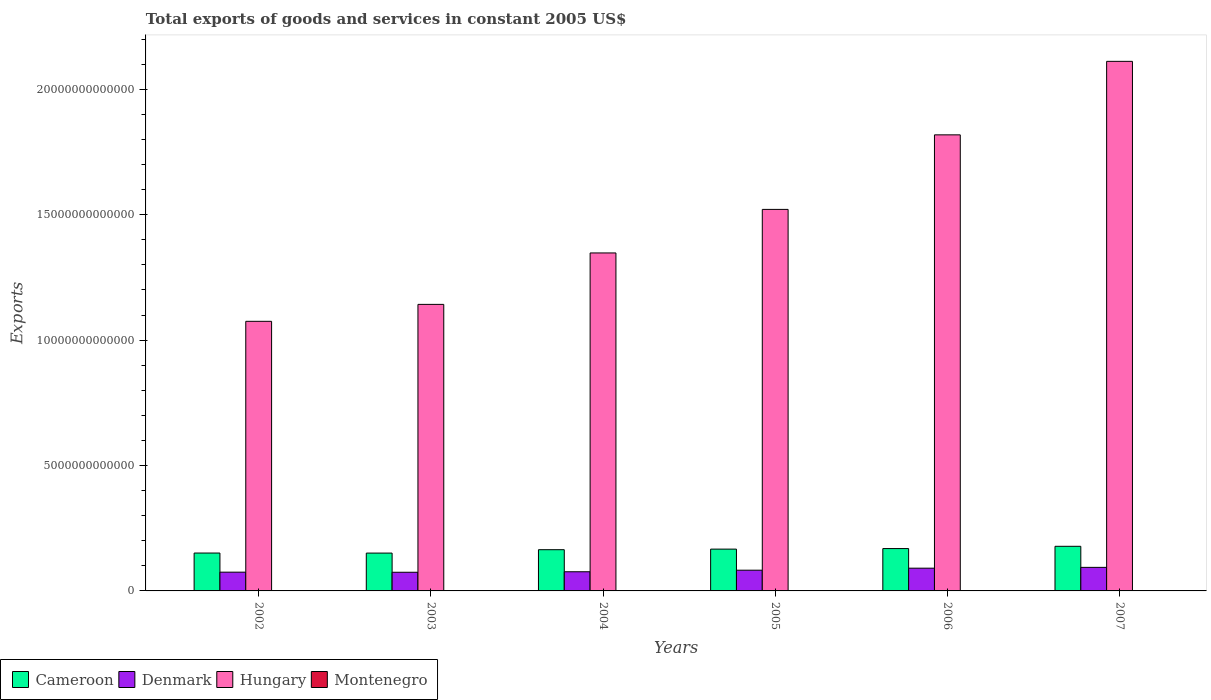How many groups of bars are there?
Your answer should be very brief. 6. Are the number of bars per tick equal to the number of legend labels?
Provide a succinct answer. Yes. How many bars are there on the 4th tick from the left?
Provide a short and direct response. 4. How many bars are there on the 6th tick from the right?
Your answer should be very brief. 4. What is the label of the 6th group of bars from the left?
Provide a succinct answer. 2007. What is the total exports of goods and services in Cameroon in 2005?
Ensure brevity in your answer.  1.67e+12. Across all years, what is the maximum total exports of goods and services in Cameroon?
Provide a succinct answer. 1.78e+12. Across all years, what is the minimum total exports of goods and services in Denmark?
Provide a short and direct response. 7.44e+11. In which year was the total exports of goods and services in Cameroon minimum?
Provide a short and direct response. 2003. What is the total total exports of goods and services in Hungary in the graph?
Your answer should be compact. 9.02e+13. What is the difference between the total exports of goods and services in Hungary in 2002 and that in 2003?
Keep it short and to the point. -6.75e+11. What is the difference between the total exports of goods and services in Cameroon in 2007 and the total exports of goods and services in Hungary in 2004?
Provide a succinct answer. -1.17e+13. What is the average total exports of goods and services in Montenegro per year?
Ensure brevity in your answer.  7.18e+08. In the year 2004, what is the difference between the total exports of goods and services in Hungary and total exports of goods and services in Denmark?
Offer a very short reply. 1.27e+13. What is the ratio of the total exports of goods and services in Hungary in 2002 to that in 2005?
Give a very brief answer. 0.71. Is the total exports of goods and services in Montenegro in 2002 less than that in 2005?
Your answer should be very brief. Yes. Is the difference between the total exports of goods and services in Hungary in 2003 and 2005 greater than the difference between the total exports of goods and services in Denmark in 2003 and 2005?
Ensure brevity in your answer.  No. What is the difference between the highest and the second highest total exports of goods and services in Denmark?
Your answer should be very brief. 3.24e+1. What is the difference between the highest and the lowest total exports of goods and services in Montenegro?
Ensure brevity in your answer.  5.13e+08. Is the sum of the total exports of goods and services in Montenegro in 2006 and 2007 greater than the maximum total exports of goods and services in Hungary across all years?
Your answer should be compact. No. What does the 2nd bar from the left in 2007 represents?
Provide a succinct answer. Denmark. What does the 2nd bar from the right in 2007 represents?
Keep it short and to the point. Hungary. Is it the case that in every year, the sum of the total exports of goods and services in Cameroon and total exports of goods and services in Denmark is greater than the total exports of goods and services in Hungary?
Your answer should be very brief. No. What is the difference between two consecutive major ticks on the Y-axis?
Make the answer very short. 5.00e+12. Are the values on the major ticks of Y-axis written in scientific E-notation?
Your response must be concise. No. Does the graph contain any zero values?
Ensure brevity in your answer.  No. Does the graph contain grids?
Your response must be concise. No. How many legend labels are there?
Your answer should be very brief. 4. What is the title of the graph?
Keep it short and to the point. Total exports of goods and services in constant 2005 US$. Does "Argentina" appear as one of the legend labels in the graph?
Provide a succinct answer. No. What is the label or title of the Y-axis?
Provide a short and direct response. Exports. What is the Exports of Cameroon in 2002?
Make the answer very short. 1.51e+12. What is the Exports of Denmark in 2002?
Offer a terse response. 7.48e+11. What is the Exports in Hungary in 2002?
Provide a short and direct response. 1.08e+13. What is the Exports in Montenegro in 2002?
Your answer should be very brief. 5.32e+08. What is the Exports in Cameroon in 2003?
Give a very brief answer. 1.51e+12. What is the Exports of Denmark in 2003?
Give a very brief answer. 7.44e+11. What is the Exports of Hungary in 2003?
Your answer should be compact. 1.14e+13. What is the Exports of Montenegro in 2003?
Make the answer very short. 4.53e+08. What is the Exports in Cameroon in 2004?
Keep it short and to the point. 1.64e+12. What is the Exports of Denmark in 2004?
Give a very brief answer. 7.64e+11. What is the Exports in Hungary in 2004?
Provide a short and direct response. 1.35e+13. What is the Exports in Montenegro in 2004?
Offer a terse response. 6.65e+08. What is the Exports of Cameroon in 2005?
Your answer should be compact. 1.67e+12. What is the Exports of Denmark in 2005?
Give a very brief answer. 8.26e+11. What is the Exports of Hungary in 2005?
Offer a very short reply. 1.52e+13. What is the Exports of Montenegro in 2005?
Provide a succinct answer. 7.45e+08. What is the Exports of Cameroon in 2006?
Offer a terse response. 1.69e+12. What is the Exports of Denmark in 2006?
Offer a very short reply. 9.07e+11. What is the Exports of Hungary in 2006?
Your answer should be very brief. 1.82e+13. What is the Exports in Montenegro in 2006?
Offer a terse response. 9.46e+08. What is the Exports in Cameroon in 2007?
Ensure brevity in your answer.  1.78e+12. What is the Exports in Denmark in 2007?
Your response must be concise. 9.39e+11. What is the Exports of Hungary in 2007?
Offer a terse response. 2.11e+13. What is the Exports of Montenegro in 2007?
Offer a terse response. 9.66e+08. Across all years, what is the maximum Exports of Cameroon?
Your answer should be very brief. 1.78e+12. Across all years, what is the maximum Exports in Denmark?
Give a very brief answer. 9.39e+11. Across all years, what is the maximum Exports in Hungary?
Provide a short and direct response. 2.11e+13. Across all years, what is the maximum Exports of Montenegro?
Offer a very short reply. 9.66e+08. Across all years, what is the minimum Exports in Cameroon?
Keep it short and to the point. 1.51e+12. Across all years, what is the minimum Exports of Denmark?
Keep it short and to the point. 7.44e+11. Across all years, what is the minimum Exports in Hungary?
Ensure brevity in your answer.  1.08e+13. Across all years, what is the minimum Exports in Montenegro?
Your answer should be compact. 4.53e+08. What is the total Exports in Cameroon in the graph?
Provide a succinct answer. 9.80e+12. What is the total Exports of Denmark in the graph?
Offer a very short reply. 4.93e+12. What is the total Exports of Hungary in the graph?
Your response must be concise. 9.02e+13. What is the total Exports of Montenegro in the graph?
Your response must be concise. 4.31e+09. What is the difference between the Exports in Cameroon in 2002 and that in 2003?
Your response must be concise. 1.63e+09. What is the difference between the Exports of Denmark in 2002 and that in 2003?
Ensure brevity in your answer.  3.36e+09. What is the difference between the Exports of Hungary in 2002 and that in 2003?
Your answer should be very brief. -6.75e+11. What is the difference between the Exports of Montenegro in 2002 and that in 2003?
Your answer should be compact. 7.89e+07. What is the difference between the Exports of Cameroon in 2002 and that in 2004?
Give a very brief answer. -1.34e+11. What is the difference between the Exports in Denmark in 2002 and that in 2004?
Ensure brevity in your answer.  -1.63e+1. What is the difference between the Exports in Hungary in 2002 and that in 2004?
Make the answer very short. -2.73e+12. What is the difference between the Exports of Montenegro in 2002 and that in 2004?
Your response must be concise. -1.33e+08. What is the difference between the Exports of Cameroon in 2002 and that in 2005?
Make the answer very short. -1.57e+11. What is the difference between the Exports in Denmark in 2002 and that in 2005?
Give a very brief answer. -7.84e+1. What is the difference between the Exports of Hungary in 2002 and that in 2005?
Your response must be concise. -4.46e+12. What is the difference between the Exports in Montenegro in 2002 and that in 2005?
Offer a terse response. -2.13e+08. What is the difference between the Exports of Cameroon in 2002 and that in 2006?
Provide a short and direct response. -1.79e+11. What is the difference between the Exports of Denmark in 2002 and that in 2006?
Keep it short and to the point. -1.59e+11. What is the difference between the Exports of Hungary in 2002 and that in 2006?
Give a very brief answer. -7.44e+12. What is the difference between the Exports of Montenegro in 2002 and that in 2006?
Give a very brief answer. -4.14e+08. What is the difference between the Exports in Cameroon in 2002 and that in 2007?
Offer a very short reply. -2.69e+11. What is the difference between the Exports of Denmark in 2002 and that in 2007?
Provide a short and direct response. -1.92e+11. What is the difference between the Exports in Hungary in 2002 and that in 2007?
Give a very brief answer. -1.04e+13. What is the difference between the Exports of Montenegro in 2002 and that in 2007?
Make the answer very short. -4.34e+08. What is the difference between the Exports in Cameroon in 2003 and that in 2004?
Your answer should be very brief. -1.35e+11. What is the difference between the Exports in Denmark in 2003 and that in 2004?
Your response must be concise. -1.96e+1. What is the difference between the Exports of Hungary in 2003 and that in 2004?
Your answer should be compact. -2.05e+12. What is the difference between the Exports of Montenegro in 2003 and that in 2004?
Your answer should be compact. -2.12e+08. What is the difference between the Exports of Cameroon in 2003 and that in 2005?
Offer a very short reply. -1.58e+11. What is the difference between the Exports of Denmark in 2003 and that in 2005?
Your answer should be very brief. -8.18e+1. What is the difference between the Exports in Hungary in 2003 and that in 2005?
Your answer should be very brief. -3.79e+12. What is the difference between the Exports of Montenegro in 2003 and that in 2005?
Keep it short and to the point. -2.92e+08. What is the difference between the Exports in Cameroon in 2003 and that in 2006?
Your answer should be compact. -1.80e+11. What is the difference between the Exports of Denmark in 2003 and that in 2006?
Your answer should be compact. -1.63e+11. What is the difference between the Exports in Hungary in 2003 and that in 2006?
Give a very brief answer. -6.76e+12. What is the difference between the Exports of Montenegro in 2003 and that in 2006?
Your answer should be very brief. -4.93e+08. What is the difference between the Exports of Cameroon in 2003 and that in 2007?
Provide a succinct answer. -2.70e+11. What is the difference between the Exports of Denmark in 2003 and that in 2007?
Ensure brevity in your answer.  -1.95e+11. What is the difference between the Exports in Hungary in 2003 and that in 2007?
Provide a succinct answer. -9.69e+12. What is the difference between the Exports in Montenegro in 2003 and that in 2007?
Your answer should be very brief. -5.13e+08. What is the difference between the Exports of Cameroon in 2004 and that in 2005?
Provide a succinct answer. -2.32e+1. What is the difference between the Exports of Denmark in 2004 and that in 2005?
Give a very brief answer. -6.22e+1. What is the difference between the Exports in Hungary in 2004 and that in 2005?
Your answer should be compact. -1.74e+12. What is the difference between the Exports in Montenegro in 2004 and that in 2005?
Your answer should be compact. -8.00e+07. What is the difference between the Exports in Cameroon in 2004 and that in 2006?
Your response must be concise. -4.51e+1. What is the difference between the Exports of Denmark in 2004 and that in 2006?
Ensure brevity in your answer.  -1.43e+11. What is the difference between the Exports in Hungary in 2004 and that in 2006?
Give a very brief answer. -4.71e+12. What is the difference between the Exports in Montenegro in 2004 and that in 2006?
Your answer should be very brief. -2.81e+08. What is the difference between the Exports of Cameroon in 2004 and that in 2007?
Make the answer very short. -1.35e+11. What is the difference between the Exports in Denmark in 2004 and that in 2007?
Provide a succinct answer. -1.75e+11. What is the difference between the Exports of Hungary in 2004 and that in 2007?
Your answer should be compact. -7.64e+12. What is the difference between the Exports of Montenegro in 2004 and that in 2007?
Ensure brevity in your answer.  -3.01e+08. What is the difference between the Exports of Cameroon in 2005 and that in 2006?
Provide a short and direct response. -2.19e+1. What is the difference between the Exports in Denmark in 2005 and that in 2006?
Your answer should be compact. -8.09e+1. What is the difference between the Exports in Hungary in 2005 and that in 2006?
Your answer should be very brief. -2.97e+12. What is the difference between the Exports in Montenegro in 2005 and that in 2006?
Offer a very short reply. -2.01e+08. What is the difference between the Exports of Cameroon in 2005 and that in 2007?
Offer a terse response. -1.12e+11. What is the difference between the Exports of Denmark in 2005 and that in 2007?
Your answer should be compact. -1.13e+11. What is the difference between the Exports in Hungary in 2005 and that in 2007?
Offer a very short reply. -5.90e+12. What is the difference between the Exports in Montenegro in 2005 and that in 2007?
Your answer should be very brief. -2.21e+08. What is the difference between the Exports in Cameroon in 2006 and that in 2007?
Give a very brief answer. -9.02e+1. What is the difference between the Exports of Denmark in 2006 and that in 2007?
Ensure brevity in your answer.  -3.24e+1. What is the difference between the Exports of Hungary in 2006 and that in 2007?
Your response must be concise. -2.93e+12. What is the difference between the Exports of Montenegro in 2006 and that in 2007?
Provide a succinct answer. -2.01e+07. What is the difference between the Exports in Cameroon in 2002 and the Exports in Denmark in 2003?
Make the answer very short. 7.66e+11. What is the difference between the Exports of Cameroon in 2002 and the Exports of Hungary in 2003?
Keep it short and to the point. -9.92e+12. What is the difference between the Exports in Cameroon in 2002 and the Exports in Montenegro in 2003?
Provide a short and direct response. 1.51e+12. What is the difference between the Exports in Denmark in 2002 and the Exports in Hungary in 2003?
Provide a short and direct response. -1.07e+13. What is the difference between the Exports of Denmark in 2002 and the Exports of Montenegro in 2003?
Offer a terse response. 7.47e+11. What is the difference between the Exports of Hungary in 2002 and the Exports of Montenegro in 2003?
Provide a short and direct response. 1.07e+13. What is the difference between the Exports in Cameroon in 2002 and the Exports in Denmark in 2004?
Keep it short and to the point. 7.46e+11. What is the difference between the Exports in Cameroon in 2002 and the Exports in Hungary in 2004?
Your answer should be compact. -1.20e+13. What is the difference between the Exports of Cameroon in 2002 and the Exports of Montenegro in 2004?
Offer a terse response. 1.51e+12. What is the difference between the Exports of Denmark in 2002 and the Exports of Hungary in 2004?
Provide a short and direct response. -1.27e+13. What is the difference between the Exports in Denmark in 2002 and the Exports in Montenegro in 2004?
Your response must be concise. 7.47e+11. What is the difference between the Exports of Hungary in 2002 and the Exports of Montenegro in 2004?
Your response must be concise. 1.07e+13. What is the difference between the Exports in Cameroon in 2002 and the Exports in Denmark in 2005?
Give a very brief answer. 6.84e+11. What is the difference between the Exports in Cameroon in 2002 and the Exports in Hungary in 2005?
Make the answer very short. -1.37e+13. What is the difference between the Exports of Cameroon in 2002 and the Exports of Montenegro in 2005?
Your response must be concise. 1.51e+12. What is the difference between the Exports of Denmark in 2002 and the Exports of Hungary in 2005?
Keep it short and to the point. -1.45e+13. What is the difference between the Exports in Denmark in 2002 and the Exports in Montenegro in 2005?
Keep it short and to the point. 7.47e+11. What is the difference between the Exports in Hungary in 2002 and the Exports in Montenegro in 2005?
Provide a succinct answer. 1.07e+13. What is the difference between the Exports of Cameroon in 2002 and the Exports of Denmark in 2006?
Ensure brevity in your answer.  6.03e+11. What is the difference between the Exports of Cameroon in 2002 and the Exports of Hungary in 2006?
Provide a short and direct response. -1.67e+13. What is the difference between the Exports in Cameroon in 2002 and the Exports in Montenegro in 2006?
Your answer should be very brief. 1.51e+12. What is the difference between the Exports of Denmark in 2002 and the Exports of Hungary in 2006?
Provide a succinct answer. -1.74e+13. What is the difference between the Exports of Denmark in 2002 and the Exports of Montenegro in 2006?
Give a very brief answer. 7.47e+11. What is the difference between the Exports of Hungary in 2002 and the Exports of Montenegro in 2006?
Offer a very short reply. 1.07e+13. What is the difference between the Exports in Cameroon in 2002 and the Exports in Denmark in 2007?
Keep it short and to the point. 5.71e+11. What is the difference between the Exports of Cameroon in 2002 and the Exports of Hungary in 2007?
Your answer should be very brief. -1.96e+13. What is the difference between the Exports of Cameroon in 2002 and the Exports of Montenegro in 2007?
Provide a succinct answer. 1.51e+12. What is the difference between the Exports in Denmark in 2002 and the Exports in Hungary in 2007?
Provide a short and direct response. -2.04e+13. What is the difference between the Exports of Denmark in 2002 and the Exports of Montenegro in 2007?
Make the answer very short. 7.47e+11. What is the difference between the Exports in Hungary in 2002 and the Exports in Montenegro in 2007?
Offer a very short reply. 1.07e+13. What is the difference between the Exports in Cameroon in 2003 and the Exports in Denmark in 2004?
Ensure brevity in your answer.  7.45e+11. What is the difference between the Exports of Cameroon in 2003 and the Exports of Hungary in 2004?
Your response must be concise. -1.20e+13. What is the difference between the Exports of Cameroon in 2003 and the Exports of Montenegro in 2004?
Provide a short and direct response. 1.51e+12. What is the difference between the Exports in Denmark in 2003 and the Exports in Hungary in 2004?
Your answer should be compact. -1.27e+13. What is the difference between the Exports of Denmark in 2003 and the Exports of Montenegro in 2004?
Offer a terse response. 7.44e+11. What is the difference between the Exports of Hungary in 2003 and the Exports of Montenegro in 2004?
Provide a short and direct response. 1.14e+13. What is the difference between the Exports in Cameroon in 2003 and the Exports in Denmark in 2005?
Provide a short and direct response. 6.83e+11. What is the difference between the Exports of Cameroon in 2003 and the Exports of Hungary in 2005?
Your answer should be very brief. -1.37e+13. What is the difference between the Exports of Cameroon in 2003 and the Exports of Montenegro in 2005?
Keep it short and to the point. 1.51e+12. What is the difference between the Exports in Denmark in 2003 and the Exports in Hungary in 2005?
Your response must be concise. -1.45e+13. What is the difference between the Exports in Denmark in 2003 and the Exports in Montenegro in 2005?
Provide a succinct answer. 7.44e+11. What is the difference between the Exports in Hungary in 2003 and the Exports in Montenegro in 2005?
Ensure brevity in your answer.  1.14e+13. What is the difference between the Exports in Cameroon in 2003 and the Exports in Denmark in 2006?
Give a very brief answer. 6.02e+11. What is the difference between the Exports of Cameroon in 2003 and the Exports of Hungary in 2006?
Ensure brevity in your answer.  -1.67e+13. What is the difference between the Exports of Cameroon in 2003 and the Exports of Montenegro in 2006?
Your response must be concise. 1.51e+12. What is the difference between the Exports of Denmark in 2003 and the Exports of Hungary in 2006?
Give a very brief answer. -1.74e+13. What is the difference between the Exports in Denmark in 2003 and the Exports in Montenegro in 2006?
Make the answer very short. 7.43e+11. What is the difference between the Exports in Hungary in 2003 and the Exports in Montenegro in 2006?
Provide a short and direct response. 1.14e+13. What is the difference between the Exports of Cameroon in 2003 and the Exports of Denmark in 2007?
Your answer should be compact. 5.69e+11. What is the difference between the Exports in Cameroon in 2003 and the Exports in Hungary in 2007?
Your answer should be compact. -1.96e+13. What is the difference between the Exports of Cameroon in 2003 and the Exports of Montenegro in 2007?
Your answer should be compact. 1.51e+12. What is the difference between the Exports in Denmark in 2003 and the Exports in Hungary in 2007?
Your answer should be very brief. -2.04e+13. What is the difference between the Exports of Denmark in 2003 and the Exports of Montenegro in 2007?
Offer a very short reply. 7.43e+11. What is the difference between the Exports of Hungary in 2003 and the Exports of Montenegro in 2007?
Give a very brief answer. 1.14e+13. What is the difference between the Exports in Cameroon in 2004 and the Exports in Denmark in 2005?
Provide a short and direct response. 8.18e+11. What is the difference between the Exports in Cameroon in 2004 and the Exports in Hungary in 2005?
Offer a terse response. -1.36e+13. What is the difference between the Exports in Cameroon in 2004 and the Exports in Montenegro in 2005?
Your response must be concise. 1.64e+12. What is the difference between the Exports of Denmark in 2004 and the Exports of Hungary in 2005?
Your response must be concise. -1.44e+13. What is the difference between the Exports of Denmark in 2004 and the Exports of Montenegro in 2005?
Provide a short and direct response. 7.63e+11. What is the difference between the Exports in Hungary in 2004 and the Exports in Montenegro in 2005?
Your answer should be compact. 1.35e+13. What is the difference between the Exports in Cameroon in 2004 and the Exports in Denmark in 2006?
Your response must be concise. 7.37e+11. What is the difference between the Exports of Cameroon in 2004 and the Exports of Hungary in 2006?
Ensure brevity in your answer.  -1.65e+13. What is the difference between the Exports of Cameroon in 2004 and the Exports of Montenegro in 2006?
Your answer should be compact. 1.64e+12. What is the difference between the Exports in Denmark in 2004 and the Exports in Hungary in 2006?
Your answer should be compact. -1.74e+13. What is the difference between the Exports of Denmark in 2004 and the Exports of Montenegro in 2006?
Offer a very short reply. 7.63e+11. What is the difference between the Exports in Hungary in 2004 and the Exports in Montenegro in 2006?
Your response must be concise. 1.35e+13. What is the difference between the Exports in Cameroon in 2004 and the Exports in Denmark in 2007?
Provide a succinct answer. 7.04e+11. What is the difference between the Exports of Cameroon in 2004 and the Exports of Hungary in 2007?
Give a very brief answer. -1.95e+13. What is the difference between the Exports of Cameroon in 2004 and the Exports of Montenegro in 2007?
Offer a very short reply. 1.64e+12. What is the difference between the Exports of Denmark in 2004 and the Exports of Hungary in 2007?
Your answer should be very brief. -2.04e+13. What is the difference between the Exports in Denmark in 2004 and the Exports in Montenegro in 2007?
Make the answer very short. 7.63e+11. What is the difference between the Exports in Hungary in 2004 and the Exports in Montenegro in 2007?
Provide a succinct answer. 1.35e+13. What is the difference between the Exports in Cameroon in 2005 and the Exports in Denmark in 2006?
Your answer should be very brief. 7.60e+11. What is the difference between the Exports of Cameroon in 2005 and the Exports of Hungary in 2006?
Your answer should be compact. -1.65e+13. What is the difference between the Exports of Cameroon in 2005 and the Exports of Montenegro in 2006?
Offer a very short reply. 1.67e+12. What is the difference between the Exports in Denmark in 2005 and the Exports in Hungary in 2006?
Give a very brief answer. -1.74e+13. What is the difference between the Exports of Denmark in 2005 and the Exports of Montenegro in 2006?
Provide a short and direct response. 8.25e+11. What is the difference between the Exports of Hungary in 2005 and the Exports of Montenegro in 2006?
Offer a terse response. 1.52e+13. What is the difference between the Exports of Cameroon in 2005 and the Exports of Denmark in 2007?
Ensure brevity in your answer.  7.28e+11. What is the difference between the Exports in Cameroon in 2005 and the Exports in Hungary in 2007?
Provide a succinct answer. -1.94e+13. What is the difference between the Exports in Cameroon in 2005 and the Exports in Montenegro in 2007?
Provide a short and direct response. 1.67e+12. What is the difference between the Exports in Denmark in 2005 and the Exports in Hungary in 2007?
Your answer should be compact. -2.03e+13. What is the difference between the Exports of Denmark in 2005 and the Exports of Montenegro in 2007?
Your answer should be compact. 8.25e+11. What is the difference between the Exports in Hungary in 2005 and the Exports in Montenegro in 2007?
Keep it short and to the point. 1.52e+13. What is the difference between the Exports in Cameroon in 2006 and the Exports in Denmark in 2007?
Keep it short and to the point. 7.50e+11. What is the difference between the Exports in Cameroon in 2006 and the Exports in Hungary in 2007?
Give a very brief answer. -1.94e+13. What is the difference between the Exports of Cameroon in 2006 and the Exports of Montenegro in 2007?
Provide a succinct answer. 1.69e+12. What is the difference between the Exports in Denmark in 2006 and the Exports in Hungary in 2007?
Offer a terse response. -2.02e+13. What is the difference between the Exports of Denmark in 2006 and the Exports of Montenegro in 2007?
Provide a short and direct response. 9.06e+11. What is the difference between the Exports of Hungary in 2006 and the Exports of Montenegro in 2007?
Ensure brevity in your answer.  1.82e+13. What is the average Exports of Cameroon per year?
Provide a succinct answer. 1.63e+12. What is the average Exports in Denmark per year?
Offer a terse response. 8.21e+11. What is the average Exports of Hungary per year?
Your answer should be very brief. 1.50e+13. What is the average Exports in Montenegro per year?
Your response must be concise. 7.18e+08. In the year 2002, what is the difference between the Exports of Cameroon and Exports of Denmark?
Offer a terse response. 7.63e+11. In the year 2002, what is the difference between the Exports in Cameroon and Exports in Hungary?
Keep it short and to the point. -9.24e+12. In the year 2002, what is the difference between the Exports of Cameroon and Exports of Montenegro?
Your answer should be compact. 1.51e+12. In the year 2002, what is the difference between the Exports of Denmark and Exports of Hungary?
Provide a short and direct response. -1.00e+13. In the year 2002, what is the difference between the Exports of Denmark and Exports of Montenegro?
Provide a short and direct response. 7.47e+11. In the year 2002, what is the difference between the Exports in Hungary and Exports in Montenegro?
Give a very brief answer. 1.07e+13. In the year 2003, what is the difference between the Exports in Cameroon and Exports in Denmark?
Provide a short and direct response. 7.64e+11. In the year 2003, what is the difference between the Exports in Cameroon and Exports in Hungary?
Offer a terse response. -9.92e+12. In the year 2003, what is the difference between the Exports of Cameroon and Exports of Montenegro?
Give a very brief answer. 1.51e+12. In the year 2003, what is the difference between the Exports in Denmark and Exports in Hungary?
Your answer should be very brief. -1.07e+13. In the year 2003, what is the difference between the Exports in Denmark and Exports in Montenegro?
Provide a short and direct response. 7.44e+11. In the year 2003, what is the difference between the Exports in Hungary and Exports in Montenegro?
Keep it short and to the point. 1.14e+13. In the year 2004, what is the difference between the Exports of Cameroon and Exports of Denmark?
Provide a succinct answer. 8.80e+11. In the year 2004, what is the difference between the Exports in Cameroon and Exports in Hungary?
Give a very brief answer. -1.18e+13. In the year 2004, what is the difference between the Exports of Cameroon and Exports of Montenegro?
Make the answer very short. 1.64e+12. In the year 2004, what is the difference between the Exports in Denmark and Exports in Hungary?
Provide a short and direct response. -1.27e+13. In the year 2004, what is the difference between the Exports in Denmark and Exports in Montenegro?
Your response must be concise. 7.63e+11. In the year 2004, what is the difference between the Exports of Hungary and Exports of Montenegro?
Make the answer very short. 1.35e+13. In the year 2005, what is the difference between the Exports in Cameroon and Exports in Denmark?
Give a very brief answer. 8.41e+11. In the year 2005, what is the difference between the Exports in Cameroon and Exports in Hungary?
Provide a short and direct response. -1.35e+13. In the year 2005, what is the difference between the Exports in Cameroon and Exports in Montenegro?
Your answer should be compact. 1.67e+12. In the year 2005, what is the difference between the Exports in Denmark and Exports in Hungary?
Your response must be concise. -1.44e+13. In the year 2005, what is the difference between the Exports in Denmark and Exports in Montenegro?
Provide a short and direct response. 8.25e+11. In the year 2005, what is the difference between the Exports in Hungary and Exports in Montenegro?
Ensure brevity in your answer.  1.52e+13. In the year 2006, what is the difference between the Exports of Cameroon and Exports of Denmark?
Ensure brevity in your answer.  7.82e+11. In the year 2006, what is the difference between the Exports of Cameroon and Exports of Hungary?
Offer a terse response. -1.65e+13. In the year 2006, what is the difference between the Exports of Cameroon and Exports of Montenegro?
Provide a succinct answer. 1.69e+12. In the year 2006, what is the difference between the Exports in Denmark and Exports in Hungary?
Provide a succinct answer. -1.73e+13. In the year 2006, what is the difference between the Exports in Denmark and Exports in Montenegro?
Keep it short and to the point. 9.06e+11. In the year 2006, what is the difference between the Exports in Hungary and Exports in Montenegro?
Provide a short and direct response. 1.82e+13. In the year 2007, what is the difference between the Exports in Cameroon and Exports in Denmark?
Give a very brief answer. 8.40e+11. In the year 2007, what is the difference between the Exports in Cameroon and Exports in Hungary?
Your response must be concise. -1.93e+13. In the year 2007, what is the difference between the Exports of Cameroon and Exports of Montenegro?
Give a very brief answer. 1.78e+12. In the year 2007, what is the difference between the Exports of Denmark and Exports of Hungary?
Ensure brevity in your answer.  -2.02e+13. In the year 2007, what is the difference between the Exports of Denmark and Exports of Montenegro?
Provide a short and direct response. 9.38e+11. In the year 2007, what is the difference between the Exports of Hungary and Exports of Montenegro?
Offer a terse response. 2.11e+13. What is the ratio of the Exports of Denmark in 2002 to that in 2003?
Offer a terse response. 1. What is the ratio of the Exports in Hungary in 2002 to that in 2003?
Your response must be concise. 0.94. What is the ratio of the Exports of Montenegro in 2002 to that in 2003?
Keep it short and to the point. 1.17. What is the ratio of the Exports in Cameroon in 2002 to that in 2004?
Offer a very short reply. 0.92. What is the ratio of the Exports in Denmark in 2002 to that in 2004?
Your answer should be compact. 0.98. What is the ratio of the Exports of Hungary in 2002 to that in 2004?
Provide a succinct answer. 0.8. What is the ratio of the Exports in Montenegro in 2002 to that in 2004?
Ensure brevity in your answer.  0.8. What is the ratio of the Exports of Cameroon in 2002 to that in 2005?
Your response must be concise. 0.91. What is the ratio of the Exports of Denmark in 2002 to that in 2005?
Offer a terse response. 0.91. What is the ratio of the Exports in Hungary in 2002 to that in 2005?
Provide a succinct answer. 0.71. What is the ratio of the Exports of Montenegro in 2002 to that in 2005?
Your answer should be very brief. 0.71. What is the ratio of the Exports in Cameroon in 2002 to that in 2006?
Give a very brief answer. 0.89. What is the ratio of the Exports of Denmark in 2002 to that in 2006?
Offer a very short reply. 0.82. What is the ratio of the Exports in Hungary in 2002 to that in 2006?
Keep it short and to the point. 0.59. What is the ratio of the Exports of Montenegro in 2002 to that in 2006?
Offer a terse response. 0.56. What is the ratio of the Exports in Cameroon in 2002 to that in 2007?
Give a very brief answer. 0.85. What is the ratio of the Exports of Denmark in 2002 to that in 2007?
Ensure brevity in your answer.  0.8. What is the ratio of the Exports of Hungary in 2002 to that in 2007?
Offer a very short reply. 0.51. What is the ratio of the Exports of Montenegro in 2002 to that in 2007?
Your answer should be compact. 0.55. What is the ratio of the Exports of Cameroon in 2003 to that in 2004?
Ensure brevity in your answer.  0.92. What is the ratio of the Exports of Denmark in 2003 to that in 2004?
Give a very brief answer. 0.97. What is the ratio of the Exports in Hungary in 2003 to that in 2004?
Provide a succinct answer. 0.85. What is the ratio of the Exports of Montenegro in 2003 to that in 2004?
Your answer should be compact. 0.68. What is the ratio of the Exports of Cameroon in 2003 to that in 2005?
Offer a terse response. 0.91. What is the ratio of the Exports in Denmark in 2003 to that in 2005?
Your response must be concise. 0.9. What is the ratio of the Exports in Hungary in 2003 to that in 2005?
Your response must be concise. 0.75. What is the ratio of the Exports of Montenegro in 2003 to that in 2005?
Your answer should be compact. 0.61. What is the ratio of the Exports of Cameroon in 2003 to that in 2006?
Offer a terse response. 0.89. What is the ratio of the Exports of Denmark in 2003 to that in 2006?
Provide a succinct answer. 0.82. What is the ratio of the Exports of Hungary in 2003 to that in 2006?
Your response must be concise. 0.63. What is the ratio of the Exports in Montenegro in 2003 to that in 2006?
Offer a very short reply. 0.48. What is the ratio of the Exports in Cameroon in 2003 to that in 2007?
Keep it short and to the point. 0.85. What is the ratio of the Exports in Denmark in 2003 to that in 2007?
Keep it short and to the point. 0.79. What is the ratio of the Exports in Hungary in 2003 to that in 2007?
Your answer should be very brief. 0.54. What is the ratio of the Exports in Montenegro in 2003 to that in 2007?
Offer a very short reply. 0.47. What is the ratio of the Exports of Cameroon in 2004 to that in 2005?
Your response must be concise. 0.99. What is the ratio of the Exports of Denmark in 2004 to that in 2005?
Offer a terse response. 0.92. What is the ratio of the Exports of Hungary in 2004 to that in 2005?
Provide a short and direct response. 0.89. What is the ratio of the Exports of Montenegro in 2004 to that in 2005?
Offer a terse response. 0.89. What is the ratio of the Exports in Cameroon in 2004 to that in 2006?
Your answer should be very brief. 0.97. What is the ratio of the Exports in Denmark in 2004 to that in 2006?
Give a very brief answer. 0.84. What is the ratio of the Exports of Hungary in 2004 to that in 2006?
Offer a very short reply. 0.74. What is the ratio of the Exports in Montenegro in 2004 to that in 2006?
Provide a succinct answer. 0.7. What is the ratio of the Exports in Cameroon in 2004 to that in 2007?
Ensure brevity in your answer.  0.92. What is the ratio of the Exports in Denmark in 2004 to that in 2007?
Your answer should be very brief. 0.81. What is the ratio of the Exports of Hungary in 2004 to that in 2007?
Keep it short and to the point. 0.64. What is the ratio of the Exports in Montenegro in 2004 to that in 2007?
Ensure brevity in your answer.  0.69. What is the ratio of the Exports in Denmark in 2005 to that in 2006?
Your answer should be compact. 0.91. What is the ratio of the Exports in Hungary in 2005 to that in 2006?
Provide a short and direct response. 0.84. What is the ratio of the Exports of Montenegro in 2005 to that in 2006?
Ensure brevity in your answer.  0.79. What is the ratio of the Exports of Cameroon in 2005 to that in 2007?
Provide a short and direct response. 0.94. What is the ratio of the Exports in Denmark in 2005 to that in 2007?
Your answer should be very brief. 0.88. What is the ratio of the Exports in Hungary in 2005 to that in 2007?
Ensure brevity in your answer.  0.72. What is the ratio of the Exports in Montenegro in 2005 to that in 2007?
Make the answer very short. 0.77. What is the ratio of the Exports in Cameroon in 2006 to that in 2007?
Your response must be concise. 0.95. What is the ratio of the Exports in Denmark in 2006 to that in 2007?
Ensure brevity in your answer.  0.97. What is the ratio of the Exports of Hungary in 2006 to that in 2007?
Offer a very short reply. 0.86. What is the ratio of the Exports of Montenegro in 2006 to that in 2007?
Your response must be concise. 0.98. What is the difference between the highest and the second highest Exports in Cameroon?
Ensure brevity in your answer.  9.02e+1. What is the difference between the highest and the second highest Exports of Denmark?
Offer a very short reply. 3.24e+1. What is the difference between the highest and the second highest Exports in Hungary?
Your response must be concise. 2.93e+12. What is the difference between the highest and the second highest Exports of Montenegro?
Offer a very short reply. 2.01e+07. What is the difference between the highest and the lowest Exports of Cameroon?
Provide a short and direct response. 2.70e+11. What is the difference between the highest and the lowest Exports in Denmark?
Your answer should be very brief. 1.95e+11. What is the difference between the highest and the lowest Exports of Hungary?
Offer a very short reply. 1.04e+13. What is the difference between the highest and the lowest Exports of Montenegro?
Keep it short and to the point. 5.13e+08. 